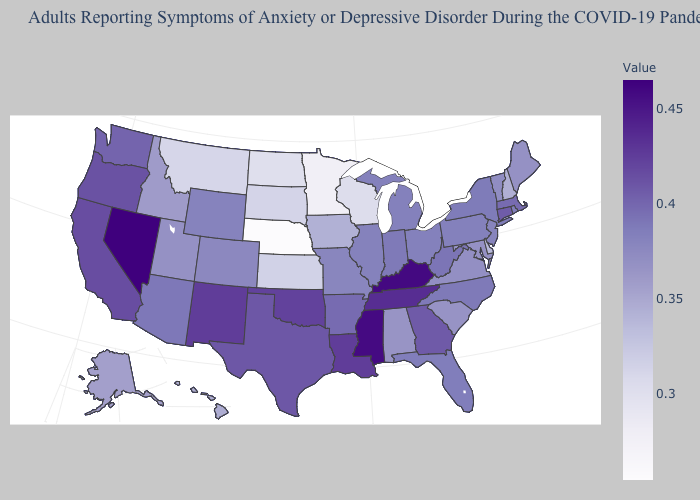Among the states that border Connecticut , which have the lowest value?
Short answer required. Rhode Island. Among the states that border Michigan , does Indiana have the highest value?
Quick response, please. Yes. Among the states that border Wisconsin , does Illinois have the highest value?
Write a very short answer. No. Which states have the lowest value in the South?
Concise answer only. Delaware. Among the states that border Ohio , does Michigan have the lowest value?
Quick response, please. Yes. 